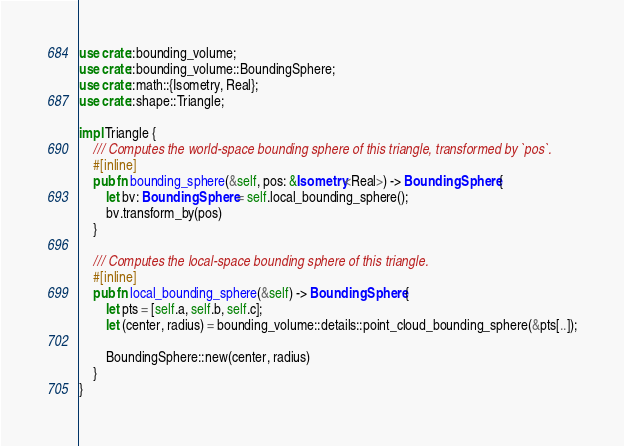<code> <loc_0><loc_0><loc_500><loc_500><_Rust_>use crate::bounding_volume;
use crate::bounding_volume::BoundingSphere;
use crate::math::{Isometry, Real};
use crate::shape::Triangle;

impl Triangle {
    /// Computes the world-space bounding sphere of this triangle, transformed by `pos`.
    #[inline]
    pub fn bounding_sphere(&self, pos: &Isometry<Real>) -> BoundingSphere {
        let bv: BoundingSphere = self.local_bounding_sphere();
        bv.transform_by(pos)
    }

    /// Computes the local-space bounding sphere of this triangle.
    #[inline]
    pub fn local_bounding_sphere(&self) -> BoundingSphere {
        let pts = [self.a, self.b, self.c];
        let (center, radius) = bounding_volume::details::point_cloud_bounding_sphere(&pts[..]);

        BoundingSphere::new(center, radius)
    }
}
</code> 